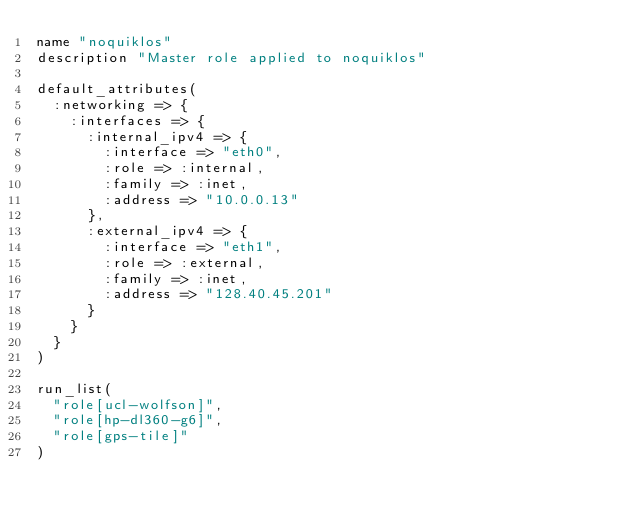<code> <loc_0><loc_0><loc_500><loc_500><_Ruby_>name "noquiklos"
description "Master role applied to noquiklos"

default_attributes(
  :networking => {
    :interfaces => {
      :internal_ipv4 => {
        :interface => "eth0",
        :role => :internal,
        :family => :inet,
        :address => "10.0.0.13"
      },
      :external_ipv4 => {
        :interface => "eth1",
        :role => :external,
        :family => :inet,
        :address => "128.40.45.201"
      }
    }
  }
)

run_list(
  "role[ucl-wolfson]",
  "role[hp-dl360-g6]",
  "role[gps-tile]"
)
</code> 